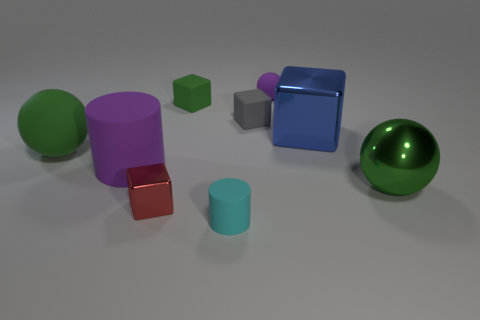How many things are big balls on the right side of the cyan rubber cylinder or large shiny cubes?
Provide a short and direct response. 2. How many objects are either brown shiny things or green spheres that are on the left side of the red metallic object?
Offer a very short reply. 1. What number of small cylinders are in front of the block in front of the big green object to the left of the tiny cylinder?
Your answer should be compact. 1. There is a cylinder that is the same size as the red metallic block; what is it made of?
Offer a very short reply. Rubber. Is there a green cube of the same size as the cyan matte cylinder?
Your answer should be compact. Yes. What is the color of the big matte cylinder?
Your answer should be very brief. Purple. There is a shiny object that is in front of the big green thing in front of the big rubber cylinder; what color is it?
Your response must be concise. Red. What shape is the green thing on the left side of the metal block that is left of the purple rubber object behind the gray matte cube?
Provide a short and direct response. Sphere. What number of small spheres have the same material as the red object?
Provide a succinct answer. 0. There is a purple thing that is behind the large rubber sphere; what number of blue shiny objects are on the left side of it?
Offer a very short reply. 0. 